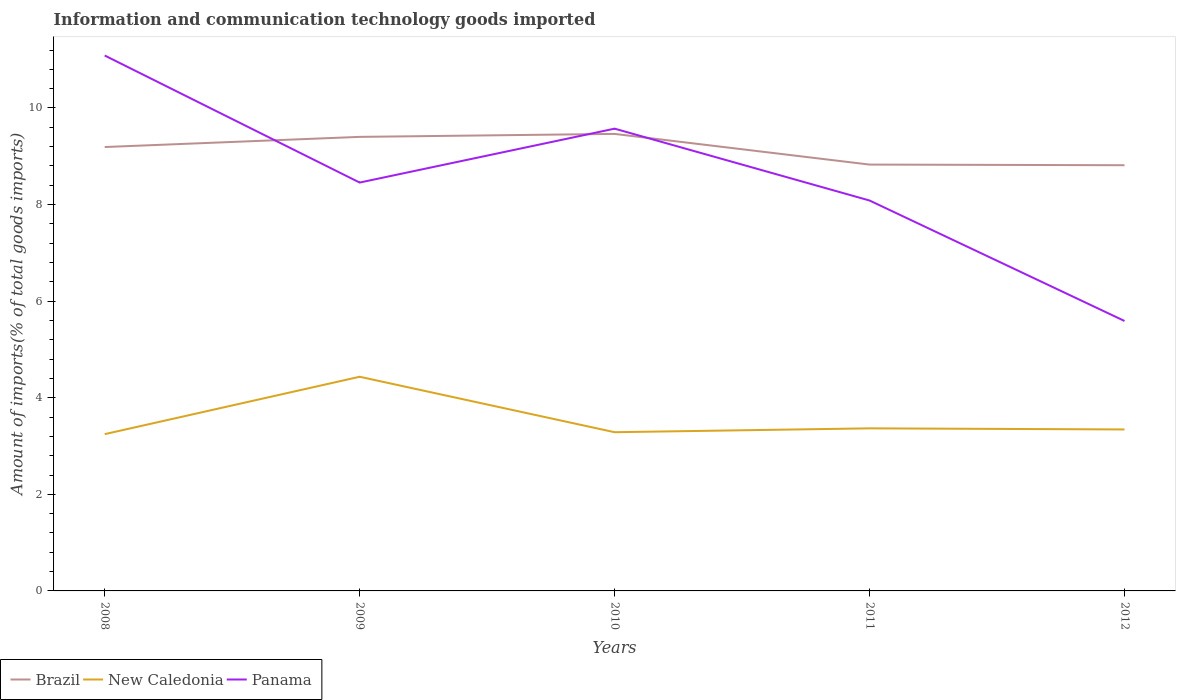Does the line corresponding to Brazil intersect with the line corresponding to Panama?
Provide a short and direct response. Yes. Across all years, what is the maximum amount of goods imported in New Caledonia?
Offer a terse response. 3.25. What is the total amount of goods imported in Panama in the graph?
Offer a terse response. -1.12. What is the difference between the highest and the second highest amount of goods imported in New Caledonia?
Offer a terse response. 1.19. How many lines are there?
Offer a terse response. 3. Are the values on the major ticks of Y-axis written in scientific E-notation?
Offer a very short reply. No. Does the graph contain any zero values?
Provide a short and direct response. No. Does the graph contain grids?
Offer a very short reply. No. How many legend labels are there?
Provide a short and direct response. 3. How are the legend labels stacked?
Offer a terse response. Horizontal. What is the title of the graph?
Make the answer very short. Information and communication technology goods imported. Does "Central African Republic" appear as one of the legend labels in the graph?
Provide a short and direct response. No. What is the label or title of the Y-axis?
Offer a terse response. Amount of imports(% of total goods imports). What is the Amount of imports(% of total goods imports) in Brazil in 2008?
Keep it short and to the point. 9.19. What is the Amount of imports(% of total goods imports) in New Caledonia in 2008?
Offer a very short reply. 3.25. What is the Amount of imports(% of total goods imports) of Panama in 2008?
Keep it short and to the point. 11.09. What is the Amount of imports(% of total goods imports) in Brazil in 2009?
Keep it short and to the point. 9.4. What is the Amount of imports(% of total goods imports) in New Caledonia in 2009?
Offer a terse response. 4.43. What is the Amount of imports(% of total goods imports) of Panama in 2009?
Keep it short and to the point. 8.46. What is the Amount of imports(% of total goods imports) in Brazil in 2010?
Your answer should be very brief. 9.46. What is the Amount of imports(% of total goods imports) of New Caledonia in 2010?
Give a very brief answer. 3.29. What is the Amount of imports(% of total goods imports) of Panama in 2010?
Offer a terse response. 9.57. What is the Amount of imports(% of total goods imports) of Brazil in 2011?
Your answer should be compact. 8.83. What is the Amount of imports(% of total goods imports) of New Caledonia in 2011?
Make the answer very short. 3.37. What is the Amount of imports(% of total goods imports) in Panama in 2011?
Ensure brevity in your answer.  8.08. What is the Amount of imports(% of total goods imports) of Brazil in 2012?
Provide a short and direct response. 8.82. What is the Amount of imports(% of total goods imports) of New Caledonia in 2012?
Give a very brief answer. 3.34. What is the Amount of imports(% of total goods imports) of Panama in 2012?
Provide a short and direct response. 5.59. Across all years, what is the maximum Amount of imports(% of total goods imports) of Brazil?
Give a very brief answer. 9.46. Across all years, what is the maximum Amount of imports(% of total goods imports) in New Caledonia?
Ensure brevity in your answer.  4.43. Across all years, what is the maximum Amount of imports(% of total goods imports) of Panama?
Offer a very short reply. 11.09. Across all years, what is the minimum Amount of imports(% of total goods imports) in Brazil?
Ensure brevity in your answer.  8.82. Across all years, what is the minimum Amount of imports(% of total goods imports) in New Caledonia?
Keep it short and to the point. 3.25. Across all years, what is the minimum Amount of imports(% of total goods imports) of Panama?
Provide a short and direct response. 5.59. What is the total Amount of imports(% of total goods imports) in Brazil in the graph?
Your response must be concise. 45.7. What is the total Amount of imports(% of total goods imports) of New Caledonia in the graph?
Offer a very short reply. 17.68. What is the total Amount of imports(% of total goods imports) of Panama in the graph?
Your answer should be very brief. 42.79. What is the difference between the Amount of imports(% of total goods imports) in Brazil in 2008 and that in 2009?
Give a very brief answer. -0.21. What is the difference between the Amount of imports(% of total goods imports) of New Caledonia in 2008 and that in 2009?
Make the answer very short. -1.19. What is the difference between the Amount of imports(% of total goods imports) in Panama in 2008 and that in 2009?
Provide a succinct answer. 2.63. What is the difference between the Amount of imports(% of total goods imports) in Brazil in 2008 and that in 2010?
Make the answer very short. -0.27. What is the difference between the Amount of imports(% of total goods imports) of New Caledonia in 2008 and that in 2010?
Your answer should be very brief. -0.04. What is the difference between the Amount of imports(% of total goods imports) of Panama in 2008 and that in 2010?
Offer a terse response. 1.51. What is the difference between the Amount of imports(% of total goods imports) of Brazil in 2008 and that in 2011?
Ensure brevity in your answer.  0.36. What is the difference between the Amount of imports(% of total goods imports) of New Caledonia in 2008 and that in 2011?
Your response must be concise. -0.12. What is the difference between the Amount of imports(% of total goods imports) in Panama in 2008 and that in 2011?
Make the answer very short. 3. What is the difference between the Amount of imports(% of total goods imports) in Brazil in 2008 and that in 2012?
Provide a short and direct response. 0.38. What is the difference between the Amount of imports(% of total goods imports) in New Caledonia in 2008 and that in 2012?
Ensure brevity in your answer.  -0.1. What is the difference between the Amount of imports(% of total goods imports) of Panama in 2008 and that in 2012?
Provide a short and direct response. 5.5. What is the difference between the Amount of imports(% of total goods imports) of Brazil in 2009 and that in 2010?
Your answer should be compact. -0.06. What is the difference between the Amount of imports(% of total goods imports) of New Caledonia in 2009 and that in 2010?
Keep it short and to the point. 1.15. What is the difference between the Amount of imports(% of total goods imports) of Panama in 2009 and that in 2010?
Offer a very short reply. -1.12. What is the difference between the Amount of imports(% of total goods imports) of Brazil in 2009 and that in 2011?
Your answer should be very brief. 0.57. What is the difference between the Amount of imports(% of total goods imports) of New Caledonia in 2009 and that in 2011?
Provide a short and direct response. 1.07. What is the difference between the Amount of imports(% of total goods imports) in Panama in 2009 and that in 2011?
Provide a succinct answer. 0.37. What is the difference between the Amount of imports(% of total goods imports) in Brazil in 2009 and that in 2012?
Provide a short and direct response. 0.59. What is the difference between the Amount of imports(% of total goods imports) in New Caledonia in 2009 and that in 2012?
Your response must be concise. 1.09. What is the difference between the Amount of imports(% of total goods imports) in Panama in 2009 and that in 2012?
Offer a very short reply. 2.87. What is the difference between the Amount of imports(% of total goods imports) of Brazil in 2010 and that in 2011?
Make the answer very short. 0.64. What is the difference between the Amount of imports(% of total goods imports) in New Caledonia in 2010 and that in 2011?
Your answer should be very brief. -0.08. What is the difference between the Amount of imports(% of total goods imports) in Panama in 2010 and that in 2011?
Provide a succinct answer. 1.49. What is the difference between the Amount of imports(% of total goods imports) of Brazil in 2010 and that in 2012?
Your answer should be very brief. 0.65. What is the difference between the Amount of imports(% of total goods imports) of New Caledonia in 2010 and that in 2012?
Your answer should be compact. -0.06. What is the difference between the Amount of imports(% of total goods imports) of Panama in 2010 and that in 2012?
Your answer should be compact. 3.98. What is the difference between the Amount of imports(% of total goods imports) in Brazil in 2011 and that in 2012?
Give a very brief answer. 0.01. What is the difference between the Amount of imports(% of total goods imports) in New Caledonia in 2011 and that in 2012?
Keep it short and to the point. 0.02. What is the difference between the Amount of imports(% of total goods imports) of Panama in 2011 and that in 2012?
Ensure brevity in your answer.  2.49. What is the difference between the Amount of imports(% of total goods imports) of Brazil in 2008 and the Amount of imports(% of total goods imports) of New Caledonia in 2009?
Offer a very short reply. 4.76. What is the difference between the Amount of imports(% of total goods imports) in Brazil in 2008 and the Amount of imports(% of total goods imports) in Panama in 2009?
Your answer should be very brief. 0.74. What is the difference between the Amount of imports(% of total goods imports) in New Caledonia in 2008 and the Amount of imports(% of total goods imports) in Panama in 2009?
Your answer should be compact. -5.21. What is the difference between the Amount of imports(% of total goods imports) of Brazil in 2008 and the Amount of imports(% of total goods imports) of New Caledonia in 2010?
Offer a very short reply. 5.91. What is the difference between the Amount of imports(% of total goods imports) in Brazil in 2008 and the Amount of imports(% of total goods imports) in Panama in 2010?
Make the answer very short. -0.38. What is the difference between the Amount of imports(% of total goods imports) of New Caledonia in 2008 and the Amount of imports(% of total goods imports) of Panama in 2010?
Ensure brevity in your answer.  -6.33. What is the difference between the Amount of imports(% of total goods imports) of Brazil in 2008 and the Amount of imports(% of total goods imports) of New Caledonia in 2011?
Provide a short and direct response. 5.83. What is the difference between the Amount of imports(% of total goods imports) in Brazil in 2008 and the Amount of imports(% of total goods imports) in Panama in 2011?
Provide a succinct answer. 1.11. What is the difference between the Amount of imports(% of total goods imports) of New Caledonia in 2008 and the Amount of imports(% of total goods imports) of Panama in 2011?
Offer a very short reply. -4.84. What is the difference between the Amount of imports(% of total goods imports) in Brazil in 2008 and the Amount of imports(% of total goods imports) in New Caledonia in 2012?
Your answer should be very brief. 5.85. What is the difference between the Amount of imports(% of total goods imports) in Brazil in 2008 and the Amount of imports(% of total goods imports) in Panama in 2012?
Give a very brief answer. 3.6. What is the difference between the Amount of imports(% of total goods imports) of New Caledonia in 2008 and the Amount of imports(% of total goods imports) of Panama in 2012?
Your answer should be compact. -2.34. What is the difference between the Amount of imports(% of total goods imports) of Brazil in 2009 and the Amount of imports(% of total goods imports) of New Caledonia in 2010?
Keep it short and to the point. 6.12. What is the difference between the Amount of imports(% of total goods imports) in Brazil in 2009 and the Amount of imports(% of total goods imports) in Panama in 2010?
Provide a short and direct response. -0.17. What is the difference between the Amount of imports(% of total goods imports) in New Caledonia in 2009 and the Amount of imports(% of total goods imports) in Panama in 2010?
Your answer should be very brief. -5.14. What is the difference between the Amount of imports(% of total goods imports) in Brazil in 2009 and the Amount of imports(% of total goods imports) in New Caledonia in 2011?
Your answer should be compact. 6.04. What is the difference between the Amount of imports(% of total goods imports) of Brazil in 2009 and the Amount of imports(% of total goods imports) of Panama in 2011?
Give a very brief answer. 1.32. What is the difference between the Amount of imports(% of total goods imports) in New Caledonia in 2009 and the Amount of imports(% of total goods imports) in Panama in 2011?
Your response must be concise. -3.65. What is the difference between the Amount of imports(% of total goods imports) in Brazil in 2009 and the Amount of imports(% of total goods imports) in New Caledonia in 2012?
Ensure brevity in your answer.  6.06. What is the difference between the Amount of imports(% of total goods imports) in Brazil in 2009 and the Amount of imports(% of total goods imports) in Panama in 2012?
Offer a terse response. 3.81. What is the difference between the Amount of imports(% of total goods imports) in New Caledonia in 2009 and the Amount of imports(% of total goods imports) in Panama in 2012?
Provide a short and direct response. -1.16. What is the difference between the Amount of imports(% of total goods imports) in Brazil in 2010 and the Amount of imports(% of total goods imports) in New Caledonia in 2011?
Ensure brevity in your answer.  6.1. What is the difference between the Amount of imports(% of total goods imports) of Brazil in 2010 and the Amount of imports(% of total goods imports) of Panama in 2011?
Make the answer very short. 1.38. What is the difference between the Amount of imports(% of total goods imports) in New Caledonia in 2010 and the Amount of imports(% of total goods imports) in Panama in 2011?
Make the answer very short. -4.8. What is the difference between the Amount of imports(% of total goods imports) of Brazil in 2010 and the Amount of imports(% of total goods imports) of New Caledonia in 2012?
Ensure brevity in your answer.  6.12. What is the difference between the Amount of imports(% of total goods imports) of Brazil in 2010 and the Amount of imports(% of total goods imports) of Panama in 2012?
Make the answer very short. 3.87. What is the difference between the Amount of imports(% of total goods imports) in New Caledonia in 2010 and the Amount of imports(% of total goods imports) in Panama in 2012?
Give a very brief answer. -2.3. What is the difference between the Amount of imports(% of total goods imports) in Brazil in 2011 and the Amount of imports(% of total goods imports) in New Caledonia in 2012?
Provide a succinct answer. 5.48. What is the difference between the Amount of imports(% of total goods imports) in Brazil in 2011 and the Amount of imports(% of total goods imports) in Panama in 2012?
Offer a terse response. 3.24. What is the difference between the Amount of imports(% of total goods imports) of New Caledonia in 2011 and the Amount of imports(% of total goods imports) of Panama in 2012?
Give a very brief answer. -2.22. What is the average Amount of imports(% of total goods imports) of Brazil per year?
Offer a very short reply. 9.14. What is the average Amount of imports(% of total goods imports) of New Caledonia per year?
Keep it short and to the point. 3.54. What is the average Amount of imports(% of total goods imports) in Panama per year?
Offer a terse response. 8.56. In the year 2008, what is the difference between the Amount of imports(% of total goods imports) of Brazil and Amount of imports(% of total goods imports) of New Caledonia?
Your answer should be compact. 5.95. In the year 2008, what is the difference between the Amount of imports(% of total goods imports) of Brazil and Amount of imports(% of total goods imports) of Panama?
Offer a very short reply. -1.9. In the year 2008, what is the difference between the Amount of imports(% of total goods imports) in New Caledonia and Amount of imports(% of total goods imports) in Panama?
Give a very brief answer. -7.84. In the year 2009, what is the difference between the Amount of imports(% of total goods imports) of Brazil and Amount of imports(% of total goods imports) of New Caledonia?
Provide a succinct answer. 4.97. In the year 2009, what is the difference between the Amount of imports(% of total goods imports) in Brazil and Amount of imports(% of total goods imports) in Panama?
Your response must be concise. 0.95. In the year 2009, what is the difference between the Amount of imports(% of total goods imports) of New Caledonia and Amount of imports(% of total goods imports) of Panama?
Provide a succinct answer. -4.02. In the year 2010, what is the difference between the Amount of imports(% of total goods imports) in Brazil and Amount of imports(% of total goods imports) in New Caledonia?
Keep it short and to the point. 6.18. In the year 2010, what is the difference between the Amount of imports(% of total goods imports) of Brazil and Amount of imports(% of total goods imports) of Panama?
Ensure brevity in your answer.  -0.11. In the year 2010, what is the difference between the Amount of imports(% of total goods imports) in New Caledonia and Amount of imports(% of total goods imports) in Panama?
Offer a very short reply. -6.29. In the year 2011, what is the difference between the Amount of imports(% of total goods imports) in Brazil and Amount of imports(% of total goods imports) in New Caledonia?
Your answer should be very brief. 5.46. In the year 2011, what is the difference between the Amount of imports(% of total goods imports) in Brazil and Amount of imports(% of total goods imports) in Panama?
Provide a short and direct response. 0.74. In the year 2011, what is the difference between the Amount of imports(% of total goods imports) of New Caledonia and Amount of imports(% of total goods imports) of Panama?
Provide a succinct answer. -4.72. In the year 2012, what is the difference between the Amount of imports(% of total goods imports) in Brazil and Amount of imports(% of total goods imports) in New Caledonia?
Ensure brevity in your answer.  5.47. In the year 2012, what is the difference between the Amount of imports(% of total goods imports) in Brazil and Amount of imports(% of total goods imports) in Panama?
Make the answer very short. 3.23. In the year 2012, what is the difference between the Amount of imports(% of total goods imports) in New Caledonia and Amount of imports(% of total goods imports) in Panama?
Your response must be concise. -2.25. What is the ratio of the Amount of imports(% of total goods imports) in Brazil in 2008 to that in 2009?
Provide a short and direct response. 0.98. What is the ratio of the Amount of imports(% of total goods imports) in New Caledonia in 2008 to that in 2009?
Make the answer very short. 0.73. What is the ratio of the Amount of imports(% of total goods imports) in Panama in 2008 to that in 2009?
Give a very brief answer. 1.31. What is the ratio of the Amount of imports(% of total goods imports) of Brazil in 2008 to that in 2010?
Provide a succinct answer. 0.97. What is the ratio of the Amount of imports(% of total goods imports) in Panama in 2008 to that in 2010?
Your response must be concise. 1.16. What is the ratio of the Amount of imports(% of total goods imports) of Brazil in 2008 to that in 2011?
Your answer should be very brief. 1.04. What is the ratio of the Amount of imports(% of total goods imports) of Panama in 2008 to that in 2011?
Make the answer very short. 1.37. What is the ratio of the Amount of imports(% of total goods imports) of Brazil in 2008 to that in 2012?
Keep it short and to the point. 1.04. What is the ratio of the Amount of imports(% of total goods imports) of New Caledonia in 2008 to that in 2012?
Offer a very short reply. 0.97. What is the ratio of the Amount of imports(% of total goods imports) in Panama in 2008 to that in 2012?
Your answer should be very brief. 1.98. What is the ratio of the Amount of imports(% of total goods imports) of Brazil in 2009 to that in 2010?
Provide a short and direct response. 0.99. What is the ratio of the Amount of imports(% of total goods imports) in New Caledonia in 2009 to that in 2010?
Offer a very short reply. 1.35. What is the ratio of the Amount of imports(% of total goods imports) of Panama in 2009 to that in 2010?
Give a very brief answer. 0.88. What is the ratio of the Amount of imports(% of total goods imports) of Brazil in 2009 to that in 2011?
Give a very brief answer. 1.06. What is the ratio of the Amount of imports(% of total goods imports) of New Caledonia in 2009 to that in 2011?
Provide a short and direct response. 1.32. What is the ratio of the Amount of imports(% of total goods imports) of Panama in 2009 to that in 2011?
Give a very brief answer. 1.05. What is the ratio of the Amount of imports(% of total goods imports) of Brazil in 2009 to that in 2012?
Keep it short and to the point. 1.07. What is the ratio of the Amount of imports(% of total goods imports) in New Caledonia in 2009 to that in 2012?
Ensure brevity in your answer.  1.33. What is the ratio of the Amount of imports(% of total goods imports) of Panama in 2009 to that in 2012?
Keep it short and to the point. 1.51. What is the ratio of the Amount of imports(% of total goods imports) of Brazil in 2010 to that in 2011?
Ensure brevity in your answer.  1.07. What is the ratio of the Amount of imports(% of total goods imports) of New Caledonia in 2010 to that in 2011?
Your answer should be compact. 0.98. What is the ratio of the Amount of imports(% of total goods imports) in Panama in 2010 to that in 2011?
Ensure brevity in your answer.  1.18. What is the ratio of the Amount of imports(% of total goods imports) of Brazil in 2010 to that in 2012?
Your answer should be very brief. 1.07. What is the ratio of the Amount of imports(% of total goods imports) in New Caledonia in 2010 to that in 2012?
Offer a very short reply. 0.98. What is the ratio of the Amount of imports(% of total goods imports) in Panama in 2010 to that in 2012?
Provide a short and direct response. 1.71. What is the ratio of the Amount of imports(% of total goods imports) in New Caledonia in 2011 to that in 2012?
Make the answer very short. 1.01. What is the ratio of the Amount of imports(% of total goods imports) in Panama in 2011 to that in 2012?
Your response must be concise. 1.45. What is the difference between the highest and the second highest Amount of imports(% of total goods imports) of Brazil?
Give a very brief answer. 0.06. What is the difference between the highest and the second highest Amount of imports(% of total goods imports) of New Caledonia?
Give a very brief answer. 1.07. What is the difference between the highest and the second highest Amount of imports(% of total goods imports) in Panama?
Offer a terse response. 1.51. What is the difference between the highest and the lowest Amount of imports(% of total goods imports) of Brazil?
Keep it short and to the point. 0.65. What is the difference between the highest and the lowest Amount of imports(% of total goods imports) in New Caledonia?
Keep it short and to the point. 1.19. What is the difference between the highest and the lowest Amount of imports(% of total goods imports) in Panama?
Make the answer very short. 5.5. 